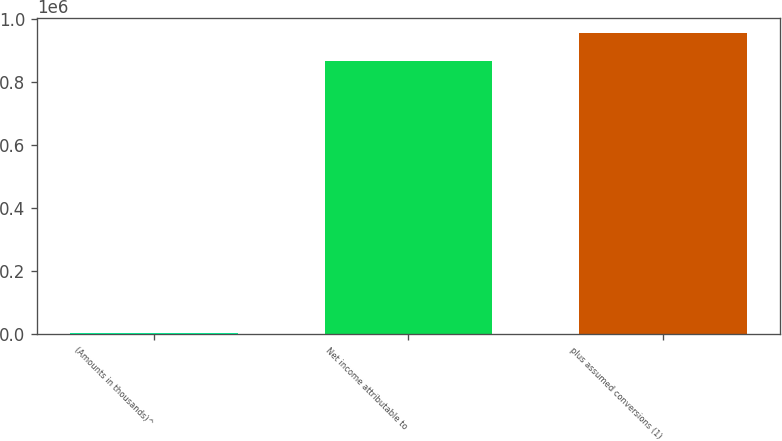<chart> <loc_0><loc_0><loc_500><loc_500><bar_chart><fcel>(Amounts in thousands)^<fcel>Net income attributable to<fcel>plus assumed conversions (1)<nl><fcel>2014<fcel>864852<fcel>955764<nl></chart> 